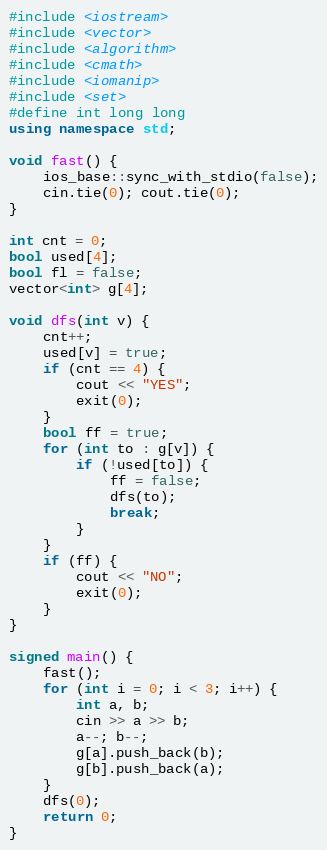<code> <loc_0><loc_0><loc_500><loc_500><_C++_>#include <iostream>
#include <vector>
#include <algorithm>
#include <cmath>
#include <iomanip>
#include <set>
#define int long long
using namespace std;

void fast() {
	ios_base::sync_with_stdio(false);
	cin.tie(0); cout.tie(0);
}

int cnt = 0;
bool used[4];
bool fl = false;
vector<int> g[4];

void dfs(int v) {
	cnt++;
	used[v] = true;
	if (cnt == 4) {
		cout << "YES";
		exit(0);
	} 
	bool ff = true;
	for (int to : g[v]) {
		if (!used[to]) {
			ff = false;
			dfs(to);
			break;
		}
	}
	if (ff) {
		cout << "NO";
		exit(0);
	}
}

signed main() {
	fast();
	for (int i = 0; i < 3; i++) {
		int a, b;
		cin >> a >> b;
		a--; b--;
		g[a].push_back(b);
		g[b].push_back(a);
	}
	dfs(0);
	return 0;
}</code> 